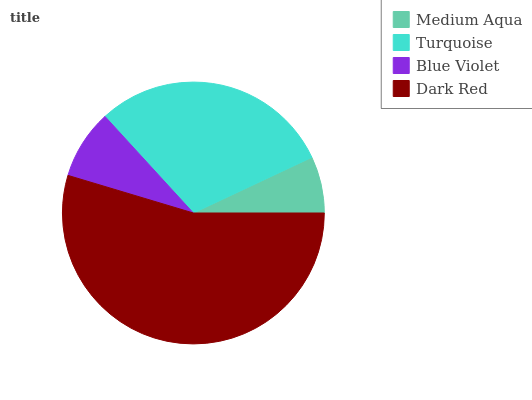Is Medium Aqua the minimum?
Answer yes or no. Yes. Is Dark Red the maximum?
Answer yes or no. Yes. Is Turquoise the minimum?
Answer yes or no. No. Is Turquoise the maximum?
Answer yes or no. No. Is Turquoise greater than Medium Aqua?
Answer yes or no. Yes. Is Medium Aqua less than Turquoise?
Answer yes or no. Yes. Is Medium Aqua greater than Turquoise?
Answer yes or no. No. Is Turquoise less than Medium Aqua?
Answer yes or no. No. Is Turquoise the high median?
Answer yes or no. Yes. Is Blue Violet the low median?
Answer yes or no. Yes. Is Medium Aqua the high median?
Answer yes or no. No. Is Turquoise the low median?
Answer yes or no. No. 